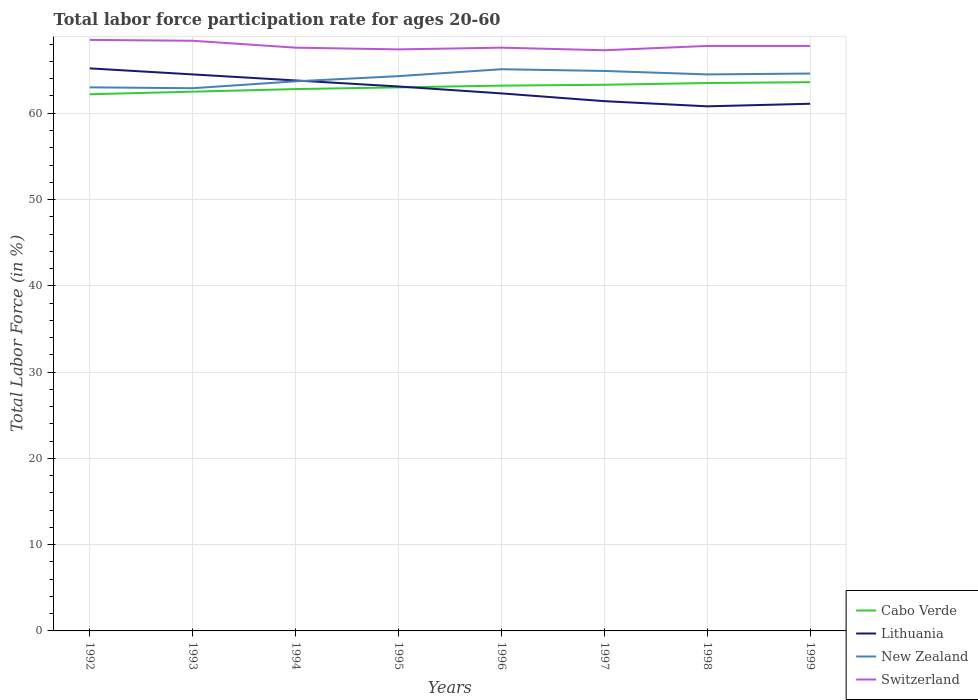Does the line corresponding to Switzerland intersect with the line corresponding to Lithuania?
Offer a terse response. No. Across all years, what is the maximum labor force participation rate in Switzerland?
Your response must be concise. 67.3. What is the total labor force participation rate in Switzerland in the graph?
Your answer should be compact. -0.4. What is the difference between the highest and the second highest labor force participation rate in Cabo Verde?
Your response must be concise. 1.4. Is the labor force participation rate in Lithuania strictly greater than the labor force participation rate in Switzerland over the years?
Give a very brief answer. Yes. How many lines are there?
Your answer should be compact. 4. How many years are there in the graph?
Keep it short and to the point. 8. What is the difference between two consecutive major ticks on the Y-axis?
Ensure brevity in your answer.  10. Are the values on the major ticks of Y-axis written in scientific E-notation?
Provide a succinct answer. No. Does the graph contain grids?
Offer a very short reply. Yes. How many legend labels are there?
Give a very brief answer. 4. What is the title of the graph?
Provide a short and direct response. Total labor force participation rate for ages 20-60. What is the label or title of the Y-axis?
Your answer should be compact. Total Labor Force (in %). What is the Total Labor Force (in %) in Cabo Verde in 1992?
Provide a short and direct response. 62.2. What is the Total Labor Force (in %) in Lithuania in 1992?
Provide a short and direct response. 65.2. What is the Total Labor Force (in %) of Switzerland in 1992?
Provide a short and direct response. 68.5. What is the Total Labor Force (in %) in Cabo Verde in 1993?
Ensure brevity in your answer.  62.5. What is the Total Labor Force (in %) in Lithuania in 1993?
Your response must be concise. 64.5. What is the Total Labor Force (in %) of New Zealand in 1993?
Offer a very short reply. 62.9. What is the Total Labor Force (in %) of Switzerland in 1993?
Your answer should be compact. 68.4. What is the Total Labor Force (in %) in Cabo Verde in 1994?
Your answer should be very brief. 62.8. What is the Total Labor Force (in %) in Lithuania in 1994?
Provide a succinct answer. 63.8. What is the Total Labor Force (in %) of New Zealand in 1994?
Ensure brevity in your answer.  63.7. What is the Total Labor Force (in %) in Switzerland in 1994?
Your response must be concise. 67.6. What is the Total Labor Force (in %) of Cabo Verde in 1995?
Make the answer very short. 63. What is the Total Labor Force (in %) of Lithuania in 1995?
Provide a short and direct response. 63.1. What is the Total Labor Force (in %) in New Zealand in 1995?
Your answer should be very brief. 64.3. What is the Total Labor Force (in %) in Switzerland in 1995?
Give a very brief answer. 67.4. What is the Total Labor Force (in %) in Cabo Verde in 1996?
Give a very brief answer. 63.2. What is the Total Labor Force (in %) in Lithuania in 1996?
Give a very brief answer. 62.3. What is the Total Labor Force (in %) in New Zealand in 1996?
Keep it short and to the point. 65.1. What is the Total Labor Force (in %) of Switzerland in 1996?
Your answer should be very brief. 67.6. What is the Total Labor Force (in %) of Cabo Verde in 1997?
Offer a very short reply. 63.3. What is the Total Labor Force (in %) of Lithuania in 1997?
Keep it short and to the point. 61.4. What is the Total Labor Force (in %) of New Zealand in 1997?
Offer a very short reply. 64.9. What is the Total Labor Force (in %) of Switzerland in 1997?
Your response must be concise. 67.3. What is the Total Labor Force (in %) of Cabo Verde in 1998?
Your response must be concise. 63.5. What is the Total Labor Force (in %) in Lithuania in 1998?
Keep it short and to the point. 60.8. What is the Total Labor Force (in %) of New Zealand in 1998?
Make the answer very short. 64.5. What is the Total Labor Force (in %) in Switzerland in 1998?
Make the answer very short. 67.8. What is the Total Labor Force (in %) of Cabo Verde in 1999?
Offer a very short reply. 63.6. What is the Total Labor Force (in %) of Lithuania in 1999?
Offer a terse response. 61.1. What is the Total Labor Force (in %) of New Zealand in 1999?
Give a very brief answer. 64.6. What is the Total Labor Force (in %) of Switzerland in 1999?
Provide a succinct answer. 67.8. Across all years, what is the maximum Total Labor Force (in %) in Cabo Verde?
Offer a terse response. 63.6. Across all years, what is the maximum Total Labor Force (in %) in Lithuania?
Give a very brief answer. 65.2. Across all years, what is the maximum Total Labor Force (in %) in New Zealand?
Make the answer very short. 65.1. Across all years, what is the maximum Total Labor Force (in %) of Switzerland?
Keep it short and to the point. 68.5. Across all years, what is the minimum Total Labor Force (in %) of Cabo Verde?
Offer a terse response. 62.2. Across all years, what is the minimum Total Labor Force (in %) in Lithuania?
Give a very brief answer. 60.8. Across all years, what is the minimum Total Labor Force (in %) of New Zealand?
Your answer should be compact. 62.9. Across all years, what is the minimum Total Labor Force (in %) of Switzerland?
Your answer should be compact. 67.3. What is the total Total Labor Force (in %) in Cabo Verde in the graph?
Make the answer very short. 504.1. What is the total Total Labor Force (in %) in Lithuania in the graph?
Make the answer very short. 502.2. What is the total Total Labor Force (in %) of New Zealand in the graph?
Give a very brief answer. 513. What is the total Total Labor Force (in %) in Switzerland in the graph?
Provide a succinct answer. 542.4. What is the difference between the Total Labor Force (in %) of New Zealand in 1992 and that in 1993?
Your answer should be very brief. 0.1. What is the difference between the Total Labor Force (in %) in Switzerland in 1992 and that in 1994?
Provide a succinct answer. 0.9. What is the difference between the Total Labor Force (in %) in Cabo Verde in 1992 and that in 1996?
Your answer should be compact. -1. What is the difference between the Total Labor Force (in %) of Lithuania in 1992 and that in 1996?
Provide a succinct answer. 2.9. What is the difference between the Total Labor Force (in %) of New Zealand in 1992 and that in 1996?
Ensure brevity in your answer.  -2.1. What is the difference between the Total Labor Force (in %) of Lithuania in 1992 and that in 1997?
Your response must be concise. 3.8. What is the difference between the Total Labor Force (in %) of Cabo Verde in 1992 and that in 1998?
Your answer should be compact. -1.3. What is the difference between the Total Labor Force (in %) in Lithuania in 1992 and that in 1998?
Ensure brevity in your answer.  4.4. What is the difference between the Total Labor Force (in %) in Switzerland in 1992 and that in 1998?
Make the answer very short. 0.7. What is the difference between the Total Labor Force (in %) of New Zealand in 1992 and that in 1999?
Keep it short and to the point. -1.6. What is the difference between the Total Labor Force (in %) in Switzerland in 1992 and that in 1999?
Ensure brevity in your answer.  0.7. What is the difference between the Total Labor Force (in %) in Cabo Verde in 1993 and that in 1994?
Provide a short and direct response. -0.3. What is the difference between the Total Labor Force (in %) in Cabo Verde in 1993 and that in 1995?
Provide a short and direct response. -0.5. What is the difference between the Total Labor Force (in %) in Cabo Verde in 1993 and that in 1996?
Make the answer very short. -0.7. What is the difference between the Total Labor Force (in %) in Lithuania in 1993 and that in 1996?
Provide a succinct answer. 2.2. What is the difference between the Total Labor Force (in %) in New Zealand in 1993 and that in 1996?
Make the answer very short. -2.2. What is the difference between the Total Labor Force (in %) of New Zealand in 1993 and that in 1997?
Make the answer very short. -2. What is the difference between the Total Labor Force (in %) of Switzerland in 1993 and that in 1997?
Your answer should be compact. 1.1. What is the difference between the Total Labor Force (in %) of Cabo Verde in 1993 and that in 1998?
Keep it short and to the point. -1. What is the difference between the Total Labor Force (in %) in Lithuania in 1993 and that in 1998?
Your answer should be very brief. 3.7. What is the difference between the Total Labor Force (in %) in Switzerland in 1993 and that in 1998?
Provide a succinct answer. 0.6. What is the difference between the Total Labor Force (in %) in Cabo Verde in 1993 and that in 1999?
Your response must be concise. -1.1. What is the difference between the Total Labor Force (in %) in Lithuania in 1993 and that in 1999?
Your answer should be compact. 3.4. What is the difference between the Total Labor Force (in %) of New Zealand in 1993 and that in 1999?
Your response must be concise. -1.7. What is the difference between the Total Labor Force (in %) of Switzerland in 1993 and that in 1999?
Your response must be concise. 0.6. What is the difference between the Total Labor Force (in %) in Cabo Verde in 1994 and that in 1995?
Provide a succinct answer. -0.2. What is the difference between the Total Labor Force (in %) of Lithuania in 1994 and that in 1995?
Offer a very short reply. 0.7. What is the difference between the Total Labor Force (in %) in New Zealand in 1994 and that in 1995?
Give a very brief answer. -0.6. What is the difference between the Total Labor Force (in %) of Switzerland in 1994 and that in 1995?
Provide a short and direct response. 0.2. What is the difference between the Total Labor Force (in %) in Lithuania in 1994 and that in 1996?
Keep it short and to the point. 1.5. What is the difference between the Total Labor Force (in %) in Switzerland in 1994 and that in 1996?
Keep it short and to the point. 0. What is the difference between the Total Labor Force (in %) of Cabo Verde in 1994 and that in 1998?
Your answer should be very brief. -0.7. What is the difference between the Total Labor Force (in %) of New Zealand in 1994 and that in 1998?
Offer a terse response. -0.8. What is the difference between the Total Labor Force (in %) in Cabo Verde in 1994 and that in 1999?
Make the answer very short. -0.8. What is the difference between the Total Labor Force (in %) in Switzerland in 1994 and that in 1999?
Give a very brief answer. -0.2. What is the difference between the Total Labor Force (in %) of Cabo Verde in 1995 and that in 1997?
Keep it short and to the point. -0.3. What is the difference between the Total Labor Force (in %) in Lithuania in 1995 and that in 1997?
Your response must be concise. 1.7. What is the difference between the Total Labor Force (in %) of Cabo Verde in 1995 and that in 1998?
Your answer should be compact. -0.5. What is the difference between the Total Labor Force (in %) in Lithuania in 1995 and that in 1998?
Offer a very short reply. 2.3. What is the difference between the Total Labor Force (in %) of New Zealand in 1995 and that in 1998?
Offer a very short reply. -0.2. What is the difference between the Total Labor Force (in %) in Cabo Verde in 1995 and that in 1999?
Your response must be concise. -0.6. What is the difference between the Total Labor Force (in %) in Lithuania in 1995 and that in 1999?
Give a very brief answer. 2. What is the difference between the Total Labor Force (in %) in Lithuania in 1996 and that in 1997?
Give a very brief answer. 0.9. What is the difference between the Total Labor Force (in %) of New Zealand in 1996 and that in 1997?
Your answer should be compact. 0.2. What is the difference between the Total Labor Force (in %) in Cabo Verde in 1996 and that in 1998?
Offer a very short reply. -0.3. What is the difference between the Total Labor Force (in %) of Lithuania in 1996 and that in 1998?
Your answer should be very brief. 1.5. What is the difference between the Total Labor Force (in %) of Cabo Verde in 1996 and that in 1999?
Provide a succinct answer. -0.4. What is the difference between the Total Labor Force (in %) of Lithuania in 1996 and that in 1999?
Your answer should be compact. 1.2. What is the difference between the Total Labor Force (in %) of New Zealand in 1996 and that in 1999?
Give a very brief answer. 0.5. What is the difference between the Total Labor Force (in %) in Switzerland in 1996 and that in 1999?
Ensure brevity in your answer.  -0.2. What is the difference between the Total Labor Force (in %) of New Zealand in 1997 and that in 1998?
Offer a very short reply. 0.4. What is the difference between the Total Labor Force (in %) in Switzerland in 1997 and that in 1998?
Ensure brevity in your answer.  -0.5. What is the difference between the Total Labor Force (in %) in Cabo Verde in 1998 and that in 1999?
Offer a terse response. -0.1. What is the difference between the Total Labor Force (in %) in Lithuania in 1998 and that in 1999?
Your response must be concise. -0.3. What is the difference between the Total Labor Force (in %) of New Zealand in 1998 and that in 1999?
Provide a short and direct response. -0.1. What is the difference between the Total Labor Force (in %) in Cabo Verde in 1992 and the Total Labor Force (in %) in Lithuania in 1993?
Provide a succinct answer. -2.3. What is the difference between the Total Labor Force (in %) in Lithuania in 1992 and the Total Labor Force (in %) in New Zealand in 1993?
Make the answer very short. 2.3. What is the difference between the Total Labor Force (in %) of Lithuania in 1992 and the Total Labor Force (in %) of Switzerland in 1993?
Give a very brief answer. -3.2. What is the difference between the Total Labor Force (in %) in New Zealand in 1992 and the Total Labor Force (in %) in Switzerland in 1993?
Your answer should be compact. -5.4. What is the difference between the Total Labor Force (in %) of Cabo Verde in 1992 and the Total Labor Force (in %) of Lithuania in 1994?
Ensure brevity in your answer.  -1.6. What is the difference between the Total Labor Force (in %) in New Zealand in 1992 and the Total Labor Force (in %) in Switzerland in 1994?
Keep it short and to the point. -4.6. What is the difference between the Total Labor Force (in %) of Cabo Verde in 1992 and the Total Labor Force (in %) of New Zealand in 1995?
Your response must be concise. -2.1. What is the difference between the Total Labor Force (in %) in Cabo Verde in 1992 and the Total Labor Force (in %) in Switzerland in 1995?
Keep it short and to the point. -5.2. What is the difference between the Total Labor Force (in %) of Cabo Verde in 1992 and the Total Labor Force (in %) of Lithuania in 1996?
Ensure brevity in your answer.  -0.1. What is the difference between the Total Labor Force (in %) in Lithuania in 1992 and the Total Labor Force (in %) in New Zealand in 1996?
Offer a very short reply. 0.1. What is the difference between the Total Labor Force (in %) of New Zealand in 1992 and the Total Labor Force (in %) of Switzerland in 1996?
Ensure brevity in your answer.  -4.6. What is the difference between the Total Labor Force (in %) of Cabo Verde in 1992 and the Total Labor Force (in %) of Lithuania in 1998?
Ensure brevity in your answer.  1.4. What is the difference between the Total Labor Force (in %) in Cabo Verde in 1992 and the Total Labor Force (in %) in New Zealand in 1998?
Give a very brief answer. -2.3. What is the difference between the Total Labor Force (in %) in New Zealand in 1992 and the Total Labor Force (in %) in Switzerland in 1998?
Ensure brevity in your answer.  -4.8. What is the difference between the Total Labor Force (in %) of Cabo Verde in 1992 and the Total Labor Force (in %) of Lithuania in 1999?
Offer a terse response. 1.1. What is the difference between the Total Labor Force (in %) in Cabo Verde in 1992 and the Total Labor Force (in %) in New Zealand in 1999?
Your response must be concise. -2.4. What is the difference between the Total Labor Force (in %) of Cabo Verde in 1992 and the Total Labor Force (in %) of Switzerland in 1999?
Offer a terse response. -5.6. What is the difference between the Total Labor Force (in %) in Lithuania in 1992 and the Total Labor Force (in %) in New Zealand in 1999?
Make the answer very short. 0.6. What is the difference between the Total Labor Force (in %) of New Zealand in 1992 and the Total Labor Force (in %) of Switzerland in 1999?
Provide a succinct answer. -4.8. What is the difference between the Total Labor Force (in %) of Cabo Verde in 1993 and the Total Labor Force (in %) of Lithuania in 1994?
Offer a very short reply. -1.3. What is the difference between the Total Labor Force (in %) in Cabo Verde in 1993 and the Total Labor Force (in %) in New Zealand in 1994?
Offer a terse response. -1.2. What is the difference between the Total Labor Force (in %) of Lithuania in 1993 and the Total Labor Force (in %) of New Zealand in 1994?
Make the answer very short. 0.8. What is the difference between the Total Labor Force (in %) of Lithuania in 1993 and the Total Labor Force (in %) of Switzerland in 1994?
Make the answer very short. -3.1. What is the difference between the Total Labor Force (in %) in Cabo Verde in 1993 and the Total Labor Force (in %) in New Zealand in 1995?
Your answer should be compact. -1.8. What is the difference between the Total Labor Force (in %) in New Zealand in 1993 and the Total Labor Force (in %) in Switzerland in 1995?
Offer a very short reply. -4.5. What is the difference between the Total Labor Force (in %) in Cabo Verde in 1993 and the Total Labor Force (in %) in Lithuania in 1996?
Provide a short and direct response. 0.2. What is the difference between the Total Labor Force (in %) in Lithuania in 1993 and the Total Labor Force (in %) in New Zealand in 1996?
Your answer should be compact. -0.6. What is the difference between the Total Labor Force (in %) in Lithuania in 1993 and the Total Labor Force (in %) in Switzerland in 1996?
Your response must be concise. -3.1. What is the difference between the Total Labor Force (in %) of Cabo Verde in 1993 and the Total Labor Force (in %) of Lithuania in 1997?
Your answer should be very brief. 1.1. What is the difference between the Total Labor Force (in %) of Cabo Verde in 1993 and the Total Labor Force (in %) of New Zealand in 1997?
Offer a terse response. -2.4. What is the difference between the Total Labor Force (in %) of Cabo Verde in 1993 and the Total Labor Force (in %) of Switzerland in 1997?
Give a very brief answer. -4.8. What is the difference between the Total Labor Force (in %) in Lithuania in 1993 and the Total Labor Force (in %) in New Zealand in 1997?
Provide a short and direct response. -0.4. What is the difference between the Total Labor Force (in %) of Cabo Verde in 1993 and the Total Labor Force (in %) of New Zealand in 1998?
Make the answer very short. -2. What is the difference between the Total Labor Force (in %) in New Zealand in 1993 and the Total Labor Force (in %) in Switzerland in 1998?
Your answer should be very brief. -4.9. What is the difference between the Total Labor Force (in %) in Cabo Verde in 1993 and the Total Labor Force (in %) in New Zealand in 1999?
Provide a succinct answer. -2.1. What is the difference between the Total Labor Force (in %) in Lithuania in 1993 and the Total Labor Force (in %) in New Zealand in 1999?
Your answer should be very brief. -0.1. What is the difference between the Total Labor Force (in %) of Cabo Verde in 1994 and the Total Labor Force (in %) of Lithuania in 1995?
Your answer should be compact. -0.3. What is the difference between the Total Labor Force (in %) of Cabo Verde in 1994 and the Total Labor Force (in %) of New Zealand in 1996?
Give a very brief answer. -2.3. What is the difference between the Total Labor Force (in %) in Cabo Verde in 1994 and the Total Labor Force (in %) in Switzerland in 1996?
Your response must be concise. -4.8. What is the difference between the Total Labor Force (in %) in New Zealand in 1994 and the Total Labor Force (in %) in Switzerland in 1996?
Offer a very short reply. -3.9. What is the difference between the Total Labor Force (in %) in Cabo Verde in 1994 and the Total Labor Force (in %) in New Zealand in 1997?
Offer a very short reply. -2.1. What is the difference between the Total Labor Force (in %) in Cabo Verde in 1994 and the Total Labor Force (in %) in Switzerland in 1997?
Your answer should be compact. -4.5. What is the difference between the Total Labor Force (in %) in New Zealand in 1994 and the Total Labor Force (in %) in Switzerland in 1997?
Offer a very short reply. -3.6. What is the difference between the Total Labor Force (in %) in Cabo Verde in 1994 and the Total Labor Force (in %) in Lithuania in 1998?
Keep it short and to the point. 2. What is the difference between the Total Labor Force (in %) in Cabo Verde in 1994 and the Total Labor Force (in %) in New Zealand in 1998?
Your answer should be compact. -1.7. What is the difference between the Total Labor Force (in %) in Lithuania in 1994 and the Total Labor Force (in %) in New Zealand in 1998?
Make the answer very short. -0.7. What is the difference between the Total Labor Force (in %) of Cabo Verde in 1994 and the Total Labor Force (in %) of New Zealand in 1999?
Make the answer very short. -1.8. What is the difference between the Total Labor Force (in %) in Cabo Verde in 1995 and the Total Labor Force (in %) in New Zealand in 1996?
Your response must be concise. -2.1. What is the difference between the Total Labor Force (in %) of Cabo Verde in 1995 and the Total Labor Force (in %) of Switzerland in 1996?
Provide a succinct answer. -4.6. What is the difference between the Total Labor Force (in %) in Lithuania in 1995 and the Total Labor Force (in %) in New Zealand in 1996?
Your response must be concise. -2. What is the difference between the Total Labor Force (in %) of Cabo Verde in 1995 and the Total Labor Force (in %) of New Zealand in 1997?
Make the answer very short. -1.9. What is the difference between the Total Labor Force (in %) of Lithuania in 1995 and the Total Labor Force (in %) of New Zealand in 1997?
Make the answer very short. -1.8. What is the difference between the Total Labor Force (in %) of New Zealand in 1995 and the Total Labor Force (in %) of Switzerland in 1997?
Your answer should be very brief. -3. What is the difference between the Total Labor Force (in %) in Cabo Verde in 1995 and the Total Labor Force (in %) in Switzerland in 1998?
Offer a very short reply. -4.8. What is the difference between the Total Labor Force (in %) in Lithuania in 1995 and the Total Labor Force (in %) in Switzerland in 1998?
Make the answer very short. -4.7. What is the difference between the Total Labor Force (in %) of New Zealand in 1995 and the Total Labor Force (in %) of Switzerland in 1998?
Your response must be concise. -3.5. What is the difference between the Total Labor Force (in %) of Cabo Verde in 1995 and the Total Labor Force (in %) of New Zealand in 1999?
Offer a very short reply. -1.6. What is the difference between the Total Labor Force (in %) in Cabo Verde in 1995 and the Total Labor Force (in %) in Switzerland in 1999?
Provide a short and direct response. -4.8. What is the difference between the Total Labor Force (in %) of Lithuania in 1995 and the Total Labor Force (in %) of Switzerland in 1999?
Keep it short and to the point. -4.7. What is the difference between the Total Labor Force (in %) in Cabo Verde in 1996 and the Total Labor Force (in %) in Switzerland in 1997?
Give a very brief answer. -4.1. What is the difference between the Total Labor Force (in %) in Lithuania in 1996 and the Total Labor Force (in %) in New Zealand in 1997?
Keep it short and to the point. -2.6. What is the difference between the Total Labor Force (in %) in Lithuania in 1996 and the Total Labor Force (in %) in Switzerland in 1997?
Your answer should be compact. -5. What is the difference between the Total Labor Force (in %) of New Zealand in 1996 and the Total Labor Force (in %) of Switzerland in 1997?
Offer a very short reply. -2.2. What is the difference between the Total Labor Force (in %) in Cabo Verde in 1996 and the Total Labor Force (in %) in New Zealand in 1998?
Your response must be concise. -1.3. What is the difference between the Total Labor Force (in %) in Cabo Verde in 1996 and the Total Labor Force (in %) in Switzerland in 1998?
Give a very brief answer. -4.6. What is the difference between the Total Labor Force (in %) in Lithuania in 1996 and the Total Labor Force (in %) in New Zealand in 1998?
Provide a succinct answer. -2.2. What is the difference between the Total Labor Force (in %) in Cabo Verde in 1996 and the Total Labor Force (in %) in Lithuania in 1999?
Your response must be concise. 2.1. What is the difference between the Total Labor Force (in %) of Cabo Verde in 1996 and the Total Labor Force (in %) of New Zealand in 1999?
Provide a short and direct response. -1.4. What is the difference between the Total Labor Force (in %) in Cabo Verde in 1996 and the Total Labor Force (in %) in Switzerland in 1999?
Your response must be concise. -4.6. What is the difference between the Total Labor Force (in %) in Lithuania in 1996 and the Total Labor Force (in %) in Switzerland in 1999?
Offer a very short reply. -5.5. What is the difference between the Total Labor Force (in %) of New Zealand in 1996 and the Total Labor Force (in %) of Switzerland in 1999?
Give a very brief answer. -2.7. What is the difference between the Total Labor Force (in %) in Cabo Verde in 1997 and the Total Labor Force (in %) in Lithuania in 1998?
Provide a succinct answer. 2.5. What is the difference between the Total Labor Force (in %) of Cabo Verde in 1997 and the Total Labor Force (in %) of New Zealand in 1998?
Offer a terse response. -1.2. What is the difference between the Total Labor Force (in %) of Lithuania in 1997 and the Total Labor Force (in %) of Switzerland in 1998?
Keep it short and to the point. -6.4. What is the difference between the Total Labor Force (in %) in New Zealand in 1997 and the Total Labor Force (in %) in Switzerland in 1998?
Provide a short and direct response. -2.9. What is the difference between the Total Labor Force (in %) of Cabo Verde in 1997 and the Total Labor Force (in %) of New Zealand in 1999?
Your response must be concise. -1.3. What is the difference between the Total Labor Force (in %) in Cabo Verde in 1997 and the Total Labor Force (in %) in Switzerland in 1999?
Your answer should be very brief. -4.5. What is the difference between the Total Labor Force (in %) of Lithuania in 1997 and the Total Labor Force (in %) of New Zealand in 1999?
Your answer should be compact. -3.2. What is the difference between the Total Labor Force (in %) in Lithuania in 1997 and the Total Labor Force (in %) in Switzerland in 1999?
Offer a very short reply. -6.4. What is the difference between the Total Labor Force (in %) of Cabo Verde in 1998 and the Total Labor Force (in %) of New Zealand in 1999?
Give a very brief answer. -1.1. What is the difference between the Total Labor Force (in %) of Lithuania in 1998 and the Total Labor Force (in %) of Switzerland in 1999?
Your answer should be very brief. -7. What is the difference between the Total Labor Force (in %) of New Zealand in 1998 and the Total Labor Force (in %) of Switzerland in 1999?
Ensure brevity in your answer.  -3.3. What is the average Total Labor Force (in %) of Cabo Verde per year?
Ensure brevity in your answer.  63.01. What is the average Total Labor Force (in %) of Lithuania per year?
Keep it short and to the point. 62.77. What is the average Total Labor Force (in %) in New Zealand per year?
Give a very brief answer. 64.12. What is the average Total Labor Force (in %) in Switzerland per year?
Ensure brevity in your answer.  67.8. In the year 1992, what is the difference between the Total Labor Force (in %) in Cabo Verde and Total Labor Force (in %) in New Zealand?
Give a very brief answer. -0.8. In the year 1992, what is the difference between the Total Labor Force (in %) of Lithuania and Total Labor Force (in %) of Switzerland?
Give a very brief answer. -3.3. In the year 1992, what is the difference between the Total Labor Force (in %) of New Zealand and Total Labor Force (in %) of Switzerland?
Offer a terse response. -5.5. In the year 1993, what is the difference between the Total Labor Force (in %) of Cabo Verde and Total Labor Force (in %) of New Zealand?
Keep it short and to the point. -0.4. In the year 1993, what is the difference between the Total Labor Force (in %) in Lithuania and Total Labor Force (in %) in New Zealand?
Provide a short and direct response. 1.6. In the year 1993, what is the difference between the Total Labor Force (in %) in Lithuania and Total Labor Force (in %) in Switzerland?
Offer a very short reply. -3.9. In the year 1993, what is the difference between the Total Labor Force (in %) in New Zealand and Total Labor Force (in %) in Switzerland?
Offer a terse response. -5.5. In the year 1994, what is the difference between the Total Labor Force (in %) in Cabo Verde and Total Labor Force (in %) in Lithuania?
Offer a very short reply. -1. In the year 1995, what is the difference between the Total Labor Force (in %) of Cabo Verde and Total Labor Force (in %) of New Zealand?
Your response must be concise. -1.3. In the year 1995, what is the difference between the Total Labor Force (in %) of Cabo Verde and Total Labor Force (in %) of Switzerland?
Provide a short and direct response. -4.4. In the year 1995, what is the difference between the Total Labor Force (in %) in Lithuania and Total Labor Force (in %) in New Zealand?
Ensure brevity in your answer.  -1.2. In the year 1995, what is the difference between the Total Labor Force (in %) of Lithuania and Total Labor Force (in %) of Switzerland?
Keep it short and to the point. -4.3. In the year 1995, what is the difference between the Total Labor Force (in %) of New Zealand and Total Labor Force (in %) of Switzerland?
Offer a terse response. -3.1. In the year 1996, what is the difference between the Total Labor Force (in %) of Cabo Verde and Total Labor Force (in %) of Lithuania?
Keep it short and to the point. 0.9. In the year 1996, what is the difference between the Total Labor Force (in %) of Cabo Verde and Total Labor Force (in %) of Switzerland?
Provide a succinct answer. -4.4. In the year 1996, what is the difference between the Total Labor Force (in %) of Lithuania and Total Labor Force (in %) of Switzerland?
Your response must be concise. -5.3. In the year 1996, what is the difference between the Total Labor Force (in %) in New Zealand and Total Labor Force (in %) in Switzerland?
Give a very brief answer. -2.5. In the year 1997, what is the difference between the Total Labor Force (in %) of Cabo Verde and Total Labor Force (in %) of Lithuania?
Keep it short and to the point. 1.9. In the year 1997, what is the difference between the Total Labor Force (in %) of Cabo Verde and Total Labor Force (in %) of Switzerland?
Your answer should be very brief. -4. In the year 1997, what is the difference between the Total Labor Force (in %) in Lithuania and Total Labor Force (in %) in Switzerland?
Make the answer very short. -5.9. In the year 1998, what is the difference between the Total Labor Force (in %) of Cabo Verde and Total Labor Force (in %) of Lithuania?
Your answer should be compact. 2.7. In the year 1998, what is the difference between the Total Labor Force (in %) of Cabo Verde and Total Labor Force (in %) of New Zealand?
Your answer should be very brief. -1. In the year 1998, what is the difference between the Total Labor Force (in %) in Cabo Verde and Total Labor Force (in %) in Switzerland?
Your answer should be compact. -4.3. In the year 1998, what is the difference between the Total Labor Force (in %) of Lithuania and Total Labor Force (in %) of New Zealand?
Ensure brevity in your answer.  -3.7. In the year 1998, what is the difference between the Total Labor Force (in %) in Lithuania and Total Labor Force (in %) in Switzerland?
Provide a succinct answer. -7. In the year 1998, what is the difference between the Total Labor Force (in %) in New Zealand and Total Labor Force (in %) in Switzerland?
Make the answer very short. -3.3. In the year 1999, what is the difference between the Total Labor Force (in %) in Cabo Verde and Total Labor Force (in %) in New Zealand?
Ensure brevity in your answer.  -1. In the year 1999, what is the difference between the Total Labor Force (in %) in Cabo Verde and Total Labor Force (in %) in Switzerland?
Give a very brief answer. -4.2. In the year 1999, what is the difference between the Total Labor Force (in %) in Lithuania and Total Labor Force (in %) in Switzerland?
Your answer should be very brief. -6.7. In the year 1999, what is the difference between the Total Labor Force (in %) of New Zealand and Total Labor Force (in %) of Switzerland?
Offer a terse response. -3.2. What is the ratio of the Total Labor Force (in %) in Lithuania in 1992 to that in 1993?
Make the answer very short. 1.01. What is the ratio of the Total Labor Force (in %) in Switzerland in 1992 to that in 1993?
Your response must be concise. 1. What is the ratio of the Total Labor Force (in %) of Cabo Verde in 1992 to that in 1994?
Your response must be concise. 0.99. What is the ratio of the Total Labor Force (in %) of Lithuania in 1992 to that in 1994?
Keep it short and to the point. 1.02. What is the ratio of the Total Labor Force (in %) of New Zealand in 1992 to that in 1994?
Make the answer very short. 0.99. What is the ratio of the Total Labor Force (in %) of Switzerland in 1992 to that in 1994?
Your response must be concise. 1.01. What is the ratio of the Total Labor Force (in %) of Cabo Verde in 1992 to that in 1995?
Your answer should be very brief. 0.99. What is the ratio of the Total Labor Force (in %) of New Zealand in 1992 to that in 1995?
Your answer should be compact. 0.98. What is the ratio of the Total Labor Force (in %) of Switzerland in 1992 to that in 1995?
Provide a succinct answer. 1.02. What is the ratio of the Total Labor Force (in %) in Cabo Verde in 1992 to that in 1996?
Your answer should be compact. 0.98. What is the ratio of the Total Labor Force (in %) of Lithuania in 1992 to that in 1996?
Keep it short and to the point. 1.05. What is the ratio of the Total Labor Force (in %) in New Zealand in 1992 to that in 1996?
Offer a very short reply. 0.97. What is the ratio of the Total Labor Force (in %) in Switzerland in 1992 to that in 1996?
Offer a terse response. 1.01. What is the ratio of the Total Labor Force (in %) of Cabo Verde in 1992 to that in 1997?
Your answer should be very brief. 0.98. What is the ratio of the Total Labor Force (in %) in Lithuania in 1992 to that in 1997?
Make the answer very short. 1.06. What is the ratio of the Total Labor Force (in %) in New Zealand in 1992 to that in 1997?
Your response must be concise. 0.97. What is the ratio of the Total Labor Force (in %) of Switzerland in 1992 to that in 1997?
Ensure brevity in your answer.  1.02. What is the ratio of the Total Labor Force (in %) of Cabo Verde in 1992 to that in 1998?
Your response must be concise. 0.98. What is the ratio of the Total Labor Force (in %) in Lithuania in 1992 to that in 1998?
Provide a succinct answer. 1.07. What is the ratio of the Total Labor Force (in %) in New Zealand in 1992 to that in 1998?
Offer a very short reply. 0.98. What is the ratio of the Total Labor Force (in %) in Switzerland in 1992 to that in 1998?
Your response must be concise. 1.01. What is the ratio of the Total Labor Force (in %) in Cabo Verde in 1992 to that in 1999?
Keep it short and to the point. 0.98. What is the ratio of the Total Labor Force (in %) in Lithuania in 1992 to that in 1999?
Keep it short and to the point. 1.07. What is the ratio of the Total Labor Force (in %) in New Zealand in 1992 to that in 1999?
Provide a succinct answer. 0.98. What is the ratio of the Total Labor Force (in %) in Switzerland in 1992 to that in 1999?
Your answer should be compact. 1.01. What is the ratio of the Total Labor Force (in %) of Cabo Verde in 1993 to that in 1994?
Give a very brief answer. 1. What is the ratio of the Total Labor Force (in %) of New Zealand in 1993 to that in 1994?
Keep it short and to the point. 0.99. What is the ratio of the Total Labor Force (in %) of Switzerland in 1993 to that in 1994?
Provide a succinct answer. 1.01. What is the ratio of the Total Labor Force (in %) in Cabo Verde in 1993 to that in 1995?
Your answer should be very brief. 0.99. What is the ratio of the Total Labor Force (in %) of Lithuania in 1993 to that in 1995?
Make the answer very short. 1.02. What is the ratio of the Total Labor Force (in %) of New Zealand in 1993 to that in 1995?
Give a very brief answer. 0.98. What is the ratio of the Total Labor Force (in %) of Switzerland in 1993 to that in 1995?
Offer a terse response. 1.01. What is the ratio of the Total Labor Force (in %) in Cabo Verde in 1993 to that in 1996?
Offer a terse response. 0.99. What is the ratio of the Total Labor Force (in %) of Lithuania in 1993 to that in 1996?
Your answer should be very brief. 1.04. What is the ratio of the Total Labor Force (in %) of New Zealand in 1993 to that in 1996?
Provide a succinct answer. 0.97. What is the ratio of the Total Labor Force (in %) of Switzerland in 1993 to that in 1996?
Make the answer very short. 1.01. What is the ratio of the Total Labor Force (in %) of Cabo Verde in 1993 to that in 1997?
Your answer should be very brief. 0.99. What is the ratio of the Total Labor Force (in %) of Lithuania in 1993 to that in 1997?
Make the answer very short. 1.05. What is the ratio of the Total Labor Force (in %) of New Zealand in 1993 to that in 1997?
Offer a very short reply. 0.97. What is the ratio of the Total Labor Force (in %) of Switzerland in 1993 to that in 1997?
Provide a succinct answer. 1.02. What is the ratio of the Total Labor Force (in %) of Cabo Verde in 1993 to that in 1998?
Ensure brevity in your answer.  0.98. What is the ratio of the Total Labor Force (in %) of Lithuania in 1993 to that in 1998?
Provide a succinct answer. 1.06. What is the ratio of the Total Labor Force (in %) in New Zealand in 1993 to that in 1998?
Your response must be concise. 0.98. What is the ratio of the Total Labor Force (in %) in Switzerland in 1993 to that in 1998?
Provide a succinct answer. 1.01. What is the ratio of the Total Labor Force (in %) of Cabo Verde in 1993 to that in 1999?
Keep it short and to the point. 0.98. What is the ratio of the Total Labor Force (in %) of Lithuania in 1993 to that in 1999?
Make the answer very short. 1.06. What is the ratio of the Total Labor Force (in %) of New Zealand in 1993 to that in 1999?
Provide a succinct answer. 0.97. What is the ratio of the Total Labor Force (in %) of Switzerland in 1993 to that in 1999?
Provide a short and direct response. 1.01. What is the ratio of the Total Labor Force (in %) in Cabo Verde in 1994 to that in 1995?
Keep it short and to the point. 1. What is the ratio of the Total Labor Force (in %) in Lithuania in 1994 to that in 1995?
Give a very brief answer. 1.01. What is the ratio of the Total Labor Force (in %) of Cabo Verde in 1994 to that in 1996?
Keep it short and to the point. 0.99. What is the ratio of the Total Labor Force (in %) in Lithuania in 1994 to that in 1996?
Your response must be concise. 1.02. What is the ratio of the Total Labor Force (in %) in New Zealand in 1994 to that in 1996?
Your response must be concise. 0.98. What is the ratio of the Total Labor Force (in %) in Cabo Verde in 1994 to that in 1997?
Your response must be concise. 0.99. What is the ratio of the Total Labor Force (in %) of Lithuania in 1994 to that in 1997?
Your answer should be very brief. 1.04. What is the ratio of the Total Labor Force (in %) of New Zealand in 1994 to that in 1997?
Make the answer very short. 0.98. What is the ratio of the Total Labor Force (in %) of Switzerland in 1994 to that in 1997?
Your response must be concise. 1. What is the ratio of the Total Labor Force (in %) in Lithuania in 1994 to that in 1998?
Offer a very short reply. 1.05. What is the ratio of the Total Labor Force (in %) in New Zealand in 1994 to that in 1998?
Provide a succinct answer. 0.99. What is the ratio of the Total Labor Force (in %) in Cabo Verde in 1994 to that in 1999?
Your answer should be very brief. 0.99. What is the ratio of the Total Labor Force (in %) in Lithuania in 1994 to that in 1999?
Provide a succinct answer. 1.04. What is the ratio of the Total Labor Force (in %) in New Zealand in 1994 to that in 1999?
Keep it short and to the point. 0.99. What is the ratio of the Total Labor Force (in %) in Switzerland in 1994 to that in 1999?
Provide a short and direct response. 1. What is the ratio of the Total Labor Force (in %) in Cabo Verde in 1995 to that in 1996?
Give a very brief answer. 1. What is the ratio of the Total Labor Force (in %) of Lithuania in 1995 to that in 1996?
Keep it short and to the point. 1.01. What is the ratio of the Total Labor Force (in %) in New Zealand in 1995 to that in 1996?
Keep it short and to the point. 0.99. What is the ratio of the Total Labor Force (in %) in Switzerland in 1995 to that in 1996?
Your answer should be very brief. 1. What is the ratio of the Total Labor Force (in %) in Cabo Verde in 1995 to that in 1997?
Offer a terse response. 1. What is the ratio of the Total Labor Force (in %) of Lithuania in 1995 to that in 1997?
Your answer should be compact. 1.03. What is the ratio of the Total Labor Force (in %) in New Zealand in 1995 to that in 1997?
Offer a very short reply. 0.99. What is the ratio of the Total Labor Force (in %) of Lithuania in 1995 to that in 1998?
Make the answer very short. 1.04. What is the ratio of the Total Labor Force (in %) of New Zealand in 1995 to that in 1998?
Provide a succinct answer. 1. What is the ratio of the Total Labor Force (in %) of Cabo Verde in 1995 to that in 1999?
Your answer should be compact. 0.99. What is the ratio of the Total Labor Force (in %) of Lithuania in 1995 to that in 1999?
Your answer should be compact. 1.03. What is the ratio of the Total Labor Force (in %) of Cabo Verde in 1996 to that in 1997?
Keep it short and to the point. 1. What is the ratio of the Total Labor Force (in %) of Lithuania in 1996 to that in 1997?
Give a very brief answer. 1.01. What is the ratio of the Total Labor Force (in %) of New Zealand in 1996 to that in 1997?
Make the answer very short. 1. What is the ratio of the Total Labor Force (in %) in Lithuania in 1996 to that in 1998?
Provide a succinct answer. 1.02. What is the ratio of the Total Labor Force (in %) in New Zealand in 1996 to that in 1998?
Give a very brief answer. 1.01. What is the ratio of the Total Labor Force (in %) of Lithuania in 1996 to that in 1999?
Your answer should be very brief. 1.02. What is the ratio of the Total Labor Force (in %) of New Zealand in 1996 to that in 1999?
Provide a short and direct response. 1.01. What is the ratio of the Total Labor Force (in %) of Cabo Verde in 1997 to that in 1998?
Offer a very short reply. 1. What is the ratio of the Total Labor Force (in %) of Lithuania in 1997 to that in 1998?
Offer a terse response. 1.01. What is the ratio of the Total Labor Force (in %) of Switzerland in 1997 to that in 1998?
Your answer should be very brief. 0.99. What is the ratio of the Total Labor Force (in %) of Cabo Verde in 1997 to that in 1999?
Make the answer very short. 1. What is the ratio of the Total Labor Force (in %) in Switzerland in 1997 to that in 1999?
Ensure brevity in your answer.  0.99. What is the ratio of the Total Labor Force (in %) in Cabo Verde in 1998 to that in 1999?
Give a very brief answer. 1. What is the ratio of the Total Labor Force (in %) of Lithuania in 1998 to that in 1999?
Provide a short and direct response. 1. What is the ratio of the Total Labor Force (in %) of New Zealand in 1998 to that in 1999?
Give a very brief answer. 1. What is the difference between the highest and the second highest Total Labor Force (in %) of Lithuania?
Offer a terse response. 0.7. What is the difference between the highest and the second highest Total Labor Force (in %) in New Zealand?
Your answer should be very brief. 0.2. What is the difference between the highest and the second highest Total Labor Force (in %) of Switzerland?
Your answer should be very brief. 0.1. What is the difference between the highest and the lowest Total Labor Force (in %) in New Zealand?
Ensure brevity in your answer.  2.2. 